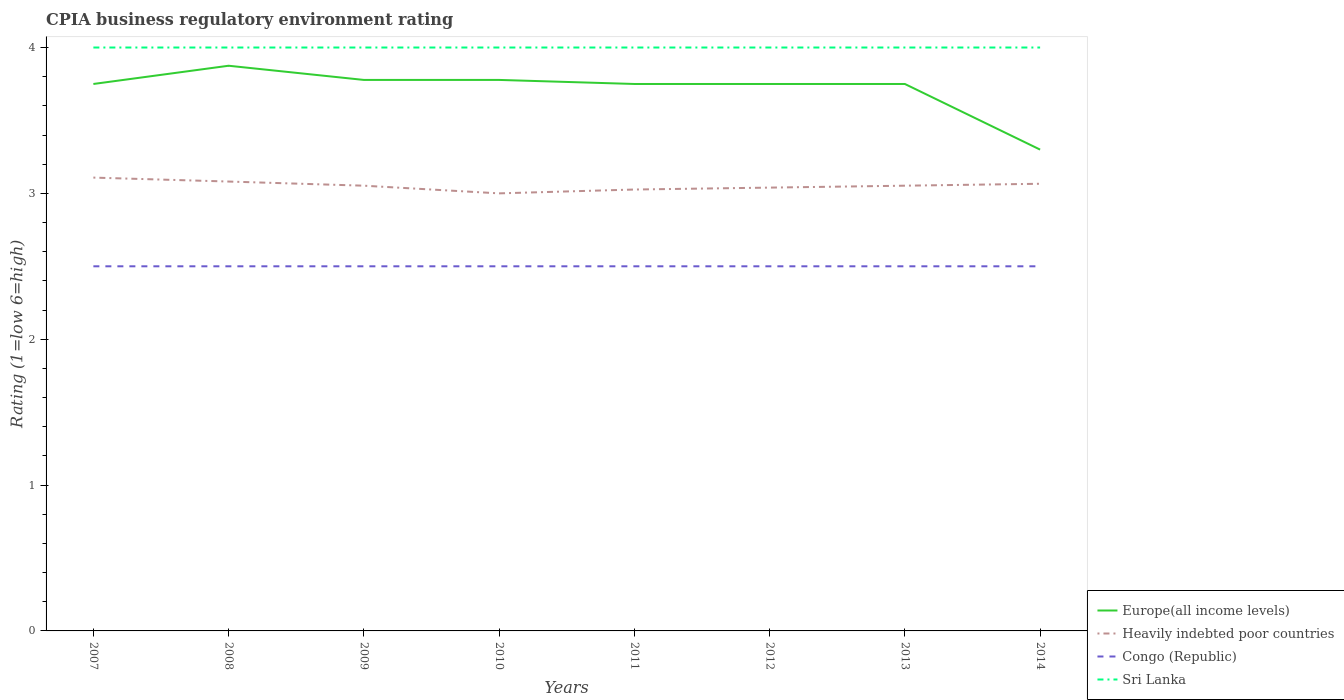Does the line corresponding to Heavily indebted poor countries intersect with the line corresponding to Congo (Republic)?
Make the answer very short. No. In which year was the CPIA rating in Heavily indebted poor countries maximum?
Offer a terse response. 2010. What is the total CPIA rating in Heavily indebted poor countries in the graph?
Keep it short and to the point. 0.03. What is the difference between the highest and the lowest CPIA rating in Sri Lanka?
Your response must be concise. 0. Is the CPIA rating in Congo (Republic) strictly greater than the CPIA rating in Heavily indebted poor countries over the years?
Provide a succinct answer. Yes. How many lines are there?
Keep it short and to the point. 4. How many years are there in the graph?
Offer a very short reply. 8. Are the values on the major ticks of Y-axis written in scientific E-notation?
Your answer should be very brief. No. Does the graph contain grids?
Your response must be concise. No. Where does the legend appear in the graph?
Your response must be concise. Bottom right. What is the title of the graph?
Offer a terse response. CPIA business regulatory environment rating. Does "Burkina Faso" appear as one of the legend labels in the graph?
Offer a very short reply. No. What is the label or title of the X-axis?
Ensure brevity in your answer.  Years. What is the Rating (1=low 6=high) in Europe(all income levels) in 2007?
Provide a succinct answer. 3.75. What is the Rating (1=low 6=high) of Heavily indebted poor countries in 2007?
Ensure brevity in your answer.  3.11. What is the Rating (1=low 6=high) of Sri Lanka in 2007?
Your response must be concise. 4. What is the Rating (1=low 6=high) of Europe(all income levels) in 2008?
Give a very brief answer. 3.88. What is the Rating (1=low 6=high) of Heavily indebted poor countries in 2008?
Make the answer very short. 3.08. What is the Rating (1=low 6=high) in Congo (Republic) in 2008?
Offer a terse response. 2.5. What is the Rating (1=low 6=high) in Europe(all income levels) in 2009?
Offer a terse response. 3.78. What is the Rating (1=low 6=high) of Heavily indebted poor countries in 2009?
Ensure brevity in your answer.  3.05. What is the Rating (1=low 6=high) in Congo (Republic) in 2009?
Provide a short and direct response. 2.5. What is the Rating (1=low 6=high) of Sri Lanka in 2009?
Offer a terse response. 4. What is the Rating (1=low 6=high) of Europe(all income levels) in 2010?
Your response must be concise. 3.78. What is the Rating (1=low 6=high) of Congo (Republic) in 2010?
Ensure brevity in your answer.  2.5. What is the Rating (1=low 6=high) in Europe(all income levels) in 2011?
Offer a terse response. 3.75. What is the Rating (1=low 6=high) of Heavily indebted poor countries in 2011?
Offer a very short reply. 3.03. What is the Rating (1=low 6=high) in Congo (Republic) in 2011?
Provide a succinct answer. 2.5. What is the Rating (1=low 6=high) in Europe(all income levels) in 2012?
Offer a very short reply. 3.75. What is the Rating (1=low 6=high) in Heavily indebted poor countries in 2012?
Your response must be concise. 3.04. What is the Rating (1=low 6=high) of Sri Lanka in 2012?
Ensure brevity in your answer.  4. What is the Rating (1=low 6=high) in Europe(all income levels) in 2013?
Ensure brevity in your answer.  3.75. What is the Rating (1=low 6=high) in Heavily indebted poor countries in 2013?
Your answer should be compact. 3.05. What is the Rating (1=low 6=high) of Heavily indebted poor countries in 2014?
Keep it short and to the point. 3.07. What is the Rating (1=low 6=high) of Congo (Republic) in 2014?
Give a very brief answer. 2.5. Across all years, what is the maximum Rating (1=low 6=high) of Europe(all income levels)?
Offer a very short reply. 3.88. Across all years, what is the maximum Rating (1=low 6=high) in Heavily indebted poor countries?
Keep it short and to the point. 3.11. Across all years, what is the maximum Rating (1=low 6=high) of Congo (Republic)?
Ensure brevity in your answer.  2.5. Across all years, what is the maximum Rating (1=low 6=high) in Sri Lanka?
Ensure brevity in your answer.  4. Across all years, what is the minimum Rating (1=low 6=high) of Congo (Republic)?
Offer a very short reply. 2.5. What is the total Rating (1=low 6=high) of Europe(all income levels) in the graph?
Make the answer very short. 29.73. What is the total Rating (1=low 6=high) of Heavily indebted poor countries in the graph?
Your answer should be compact. 24.43. What is the difference between the Rating (1=low 6=high) of Europe(all income levels) in 2007 and that in 2008?
Provide a succinct answer. -0.12. What is the difference between the Rating (1=low 6=high) in Heavily indebted poor countries in 2007 and that in 2008?
Provide a short and direct response. 0.03. What is the difference between the Rating (1=low 6=high) of Congo (Republic) in 2007 and that in 2008?
Make the answer very short. 0. What is the difference between the Rating (1=low 6=high) of Europe(all income levels) in 2007 and that in 2009?
Offer a very short reply. -0.03. What is the difference between the Rating (1=low 6=high) in Heavily indebted poor countries in 2007 and that in 2009?
Provide a succinct answer. 0.06. What is the difference between the Rating (1=low 6=high) of Europe(all income levels) in 2007 and that in 2010?
Your answer should be very brief. -0.03. What is the difference between the Rating (1=low 6=high) of Heavily indebted poor countries in 2007 and that in 2010?
Make the answer very short. 0.11. What is the difference between the Rating (1=low 6=high) of Congo (Republic) in 2007 and that in 2010?
Your response must be concise. 0. What is the difference between the Rating (1=low 6=high) of Heavily indebted poor countries in 2007 and that in 2011?
Your answer should be very brief. 0.08. What is the difference between the Rating (1=low 6=high) of Congo (Republic) in 2007 and that in 2011?
Make the answer very short. 0. What is the difference between the Rating (1=low 6=high) of Europe(all income levels) in 2007 and that in 2012?
Offer a terse response. 0. What is the difference between the Rating (1=low 6=high) in Heavily indebted poor countries in 2007 and that in 2012?
Your answer should be compact. 0.07. What is the difference between the Rating (1=low 6=high) in Europe(all income levels) in 2007 and that in 2013?
Your answer should be compact. 0. What is the difference between the Rating (1=low 6=high) in Heavily indebted poor countries in 2007 and that in 2013?
Make the answer very short. 0.06. What is the difference between the Rating (1=low 6=high) in Congo (Republic) in 2007 and that in 2013?
Make the answer very short. 0. What is the difference between the Rating (1=low 6=high) of Europe(all income levels) in 2007 and that in 2014?
Make the answer very short. 0.45. What is the difference between the Rating (1=low 6=high) of Heavily indebted poor countries in 2007 and that in 2014?
Make the answer very short. 0.04. What is the difference between the Rating (1=low 6=high) of Sri Lanka in 2007 and that in 2014?
Offer a very short reply. 0. What is the difference between the Rating (1=low 6=high) in Europe(all income levels) in 2008 and that in 2009?
Your answer should be compact. 0.1. What is the difference between the Rating (1=low 6=high) in Heavily indebted poor countries in 2008 and that in 2009?
Give a very brief answer. 0.03. What is the difference between the Rating (1=low 6=high) of Congo (Republic) in 2008 and that in 2009?
Provide a succinct answer. 0. What is the difference between the Rating (1=low 6=high) in Sri Lanka in 2008 and that in 2009?
Your response must be concise. 0. What is the difference between the Rating (1=low 6=high) in Europe(all income levels) in 2008 and that in 2010?
Provide a succinct answer. 0.1. What is the difference between the Rating (1=low 6=high) in Heavily indebted poor countries in 2008 and that in 2010?
Ensure brevity in your answer.  0.08. What is the difference between the Rating (1=low 6=high) of Congo (Republic) in 2008 and that in 2010?
Provide a succinct answer. 0. What is the difference between the Rating (1=low 6=high) of Europe(all income levels) in 2008 and that in 2011?
Offer a terse response. 0.12. What is the difference between the Rating (1=low 6=high) in Heavily indebted poor countries in 2008 and that in 2011?
Your answer should be very brief. 0.05. What is the difference between the Rating (1=low 6=high) in Congo (Republic) in 2008 and that in 2011?
Make the answer very short. 0. What is the difference between the Rating (1=low 6=high) in Sri Lanka in 2008 and that in 2011?
Offer a terse response. 0. What is the difference between the Rating (1=low 6=high) of Europe(all income levels) in 2008 and that in 2012?
Your response must be concise. 0.12. What is the difference between the Rating (1=low 6=high) in Heavily indebted poor countries in 2008 and that in 2012?
Make the answer very short. 0.04. What is the difference between the Rating (1=low 6=high) in Heavily indebted poor countries in 2008 and that in 2013?
Provide a succinct answer. 0.03. What is the difference between the Rating (1=low 6=high) in Congo (Republic) in 2008 and that in 2013?
Offer a very short reply. 0. What is the difference between the Rating (1=low 6=high) of Europe(all income levels) in 2008 and that in 2014?
Provide a succinct answer. 0.57. What is the difference between the Rating (1=low 6=high) in Heavily indebted poor countries in 2008 and that in 2014?
Keep it short and to the point. 0.02. What is the difference between the Rating (1=low 6=high) in Congo (Republic) in 2008 and that in 2014?
Offer a very short reply. 0. What is the difference between the Rating (1=low 6=high) in Europe(all income levels) in 2009 and that in 2010?
Make the answer very short. 0. What is the difference between the Rating (1=low 6=high) in Heavily indebted poor countries in 2009 and that in 2010?
Your response must be concise. 0.05. What is the difference between the Rating (1=low 6=high) in Congo (Republic) in 2009 and that in 2010?
Your response must be concise. 0. What is the difference between the Rating (1=low 6=high) of Sri Lanka in 2009 and that in 2010?
Offer a very short reply. 0. What is the difference between the Rating (1=low 6=high) of Europe(all income levels) in 2009 and that in 2011?
Provide a short and direct response. 0.03. What is the difference between the Rating (1=low 6=high) in Heavily indebted poor countries in 2009 and that in 2011?
Give a very brief answer. 0.03. What is the difference between the Rating (1=low 6=high) in Sri Lanka in 2009 and that in 2011?
Make the answer very short. 0. What is the difference between the Rating (1=low 6=high) in Europe(all income levels) in 2009 and that in 2012?
Your answer should be compact. 0.03. What is the difference between the Rating (1=low 6=high) of Heavily indebted poor countries in 2009 and that in 2012?
Offer a terse response. 0.01. What is the difference between the Rating (1=low 6=high) of Sri Lanka in 2009 and that in 2012?
Provide a short and direct response. 0. What is the difference between the Rating (1=low 6=high) of Europe(all income levels) in 2009 and that in 2013?
Provide a succinct answer. 0.03. What is the difference between the Rating (1=low 6=high) of Heavily indebted poor countries in 2009 and that in 2013?
Offer a very short reply. 0. What is the difference between the Rating (1=low 6=high) in Sri Lanka in 2009 and that in 2013?
Keep it short and to the point. 0. What is the difference between the Rating (1=low 6=high) in Europe(all income levels) in 2009 and that in 2014?
Your answer should be very brief. 0.48. What is the difference between the Rating (1=low 6=high) in Heavily indebted poor countries in 2009 and that in 2014?
Offer a very short reply. -0.01. What is the difference between the Rating (1=low 6=high) of Europe(all income levels) in 2010 and that in 2011?
Your answer should be very brief. 0.03. What is the difference between the Rating (1=low 6=high) in Heavily indebted poor countries in 2010 and that in 2011?
Make the answer very short. -0.03. What is the difference between the Rating (1=low 6=high) of Europe(all income levels) in 2010 and that in 2012?
Offer a very short reply. 0.03. What is the difference between the Rating (1=low 6=high) in Heavily indebted poor countries in 2010 and that in 2012?
Make the answer very short. -0.04. What is the difference between the Rating (1=low 6=high) of Congo (Republic) in 2010 and that in 2012?
Make the answer very short. 0. What is the difference between the Rating (1=low 6=high) of Europe(all income levels) in 2010 and that in 2013?
Make the answer very short. 0.03. What is the difference between the Rating (1=low 6=high) in Heavily indebted poor countries in 2010 and that in 2013?
Provide a succinct answer. -0.05. What is the difference between the Rating (1=low 6=high) in Congo (Republic) in 2010 and that in 2013?
Provide a short and direct response. 0. What is the difference between the Rating (1=low 6=high) of Sri Lanka in 2010 and that in 2013?
Keep it short and to the point. 0. What is the difference between the Rating (1=low 6=high) in Europe(all income levels) in 2010 and that in 2014?
Offer a very short reply. 0.48. What is the difference between the Rating (1=low 6=high) in Heavily indebted poor countries in 2010 and that in 2014?
Your response must be concise. -0.07. What is the difference between the Rating (1=low 6=high) of Sri Lanka in 2010 and that in 2014?
Keep it short and to the point. 0. What is the difference between the Rating (1=low 6=high) of Europe(all income levels) in 2011 and that in 2012?
Keep it short and to the point. 0. What is the difference between the Rating (1=low 6=high) of Heavily indebted poor countries in 2011 and that in 2012?
Offer a very short reply. -0.01. What is the difference between the Rating (1=low 6=high) in Heavily indebted poor countries in 2011 and that in 2013?
Make the answer very short. -0.03. What is the difference between the Rating (1=low 6=high) of Sri Lanka in 2011 and that in 2013?
Your response must be concise. 0. What is the difference between the Rating (1=low 6=high) of Europe(all income levels) in 2011 and that in 2014?
Your response must be concise. 0.45. What is the difference between the Rating (1=low 6=high) in Heavily indebted poor countries in 2011 and that in 2014?
Your response must be concise. -0.04. What is the difference between the Rating (1=low 6=high) in Congo (Republic) in 2011 and that in 2014?
Provide a succinct answer. 0. What is the difference between the Rating (1=low 6=high) of Sri Lanka in 2011 and that in 2014?
Offer a terse response. 0. What is the difference between the Rating (1=low 6=high) of Heavily indebted poor countries in 2012 and that in 2013?
Offer a terse response. -0.01. What is the difference between the Rating (1=low 6=high) of Europe(all income levels) in 2012 and that in 2014?
Provide a short and direct response. 0.45. What is the difference between the Rating (1=low 6=high) of Heavily indebted poor countries in 2012 and that in 2014?
Keep it short and to the point. -0.03. What is the difference between the Rating (1=low 6=high) of Sri Lanka in 2012 and that in 2014?
Provide a short and direct response. 0. What is the difference between the Rating (1=low 6=high) of Europe(all income levels) in 2013 and that in 2014?
Make the answer very short. 0.45. What is the difference between the Rating (1=low 6=high) in Heavily indebted poor countries in 2013 and that in 2014?
Make the answer very short. -0.01. What is the difference between the Rating (1=low 6=high) of Congo (Republic) in 2013 and that in 2014?
Your answer should be compact. 0. What is the difference between the Rating (1=low 6=high) in Europe(all income levels) in 2007 and the Rating (1=low 6=high) in Heavily indebted poor countries in 2008?
Ensure brevity in your answer.  0.67. What is the difference between the Rating (1=low 6=high) in Europe(all income levels) in 2007 and the Rating (1=low 6=high) in Congo (Republic) in 2008?
Your answer should be compact. 1.25. What is the difference between the Rating (1=low 6=high) of Heavily indebted poor countries in 2007 and the Rating (1=low 6=high) of Congo (Republic) in 2008?
Ensure brevity in your answer.  0.61. What is the difference between the Rating (1=low 6=high) in Heavily indebted poor countries in 2007 and the Rating (1=low 6=high) in Sri Lanka in 2008?
Make the answer very short. -0.89. What is the difference between the Rating (1=low 6=high) of Congo (Republic) in 2007 and the Rating (1=low 6=high) of Sri Lanka in 2008?
Ensure brevity in your answer.  -1.5. What is the difference between the Rating (1=low 6=high) of Europe(all income levels) in 2007 and the Rating (1=low 6=high) of Heavily indebted poor countries in 2009?
Offer a very short reply. 0.7. What is the difference between the Rating (1=low 6=high) of Europe(all income levels) in 2007 and the Rating (1=low 6=high) of Congo (Republic) in 2009?
Keep it short and to the point. 1.25. What is the difference between the Rating (1=low 6=high) of Heavily indebted poor countries in 2007 and the Rating (1=low 6=high) of Congo (Republic) in 2009?
Ensure brevity in your answer.  0.61. What is the difference between the Rating (1=low 6=high) in Heavily indebted poor countries in 2007 and the Rating (1=low 6=high) in Sri Lanka in 2009?
Make the answer very short. -0.89. What is the difference between the Rating (1=low 6=high) of Congo (Republic) in 2007 and the Rating (1=low 6=high) of Sri Lanka in 2009?
Keep it short and to the point. -1.5. What is the difference between the Rating (1=low 6=high) of Heavily indebted poor countries in 2007 and the Rating (1=low 6=high) of Congo (Republic) in 2010?
Provide a succinct answer. 0.61. What is the difference between the Rating (1=low 6=high) of Heavily indebted poor countries in 2007 and the Rating (1=low 6=high) of Sri Lanka in 2010?
Provide a short and direct response. -0.89. What is the difference between the Rating (1=low 6=high) of Congo (Republic) in 2007 and the Rating (1=low 6=high) of Sri Lanka in 2010?
Your answer should be very brief. -1.5. What is the difference between the Rating (1=low 6=high) of Europe(all income levels) in 2007 and the Rating (1=low 6=high) of Heavily indebted poor countries in 2011?
Keep it short and to the point. 0.72. What is the difference between the Rating (1=low 6=high) in Heavily indebted poor countries in 2007 and the Rating (1=low 6=high) in Congo (Republic) in 2011?
Make the answer very short. 0.61. What is the difference between the Rating (1=low 6=high) in Heavily indebted poor countries in 2007 and the Rating (1=low 6=high) in Sri Lanka in 2011?
Offer a very short reply. -0.89. What is the difference between the Rating (1=low 6=high) in Congo (Republic) in 2007 and the Rating (1=low 6=high) in Sri Lanka in 2011?
Make the answer very short. -1.5. What is the difference between the Rating (1=low 6=high) of Europe(all income levels) in 2007 and the Rating (1=low 6=high) of Heavily indebted poor countries in 2012?
Make the answer very short. 0.71. What is the difference between the Rating (1=low 6=high) in Europe(all income levels) in 2007 and the Rating (1=low 6=high) in Congo (Republic) in 2012?
Your response must be concise. 1.25. What is the difference between the Rating (1=low 6=high) of Europe(all income levels) in 2007 and the Rating (1=low 6=high) of Sri Lanka in 2012?
Offer a terse response. -0.25. What is the difference between the Rating (1=low 6=high) in Heavily indebted poor countries in 2007 and the Rating (1=low 6=high) in Congo (Republic) in 2012?
Keep it short and to the point. 0.61. What is the difference between the Rating (1=low 6=high) of Heavily indebted poor countries in 2007 and the Rating (1=low 6=high) of Sri Lanka in 2012?
Your answer should be very brief. -0.89. What is the difference between the Rating (1=low 6=high) in Congo (Republic) in 2007 and the Rating (1=low 6=high) in Sri Lanka in 2012?
Offer a terse response. -1.5. What is the difference between the Rating (1=low 6=high) of Europe(all income levels) in 2007 and the Rating (1=low 6=high) of Heavily indebted poor countries in 2013?
Give a very brief answer. 0.7. What is the difference between the Rating (1=low 6=high) in Europe(all income levels) in 2007 and the Rating (1=low 6=high) in Congo (Republic) in 2013?
Offer a terse response. 1.25. What is the difference between the Rating (1=low 6=high) of Heavily indebted poor countries in 2007 and the Rating (1=low 6=high) of Congo (Republic) in 2013?
Ensure brevity in your answer.  0.61. What is the difference between the Rating (1=low 6=high) of Heavily indebted poor countries in 2007 and the Rating (1=low 6=high) of Sri Lanka in 2013?
Offer a very short reply. -0.89. What is the difference between the Rating (1=low 6=high) of Europe(all income levels) in 2007 and the Rating (1=low 6=high) of Heavily indebted poor countries in 2014?
Your answer should be very brief. 0.68. What is the difference between the Rating (1=low 6=high) in Heavily indebted poor countries in 2007 and the Rating (1=low 6=high) in Congo (Republic) in 2014?
Provide a short and direct response. 0.61. What is the difference between the Rating (1=low 6=high) of Heavily indebted poor countries in 2007 and the Rating (1=low 6=high) of Sri Lanka in 2014?
Your answer should be compact. -0.89. What is the difference between the Rating (1=low 6=high) of Europe(all income levels) in 2008 and the Rating (1=low 6=high) of Heavily indebted poor countries in 2009?
Make the answer very short. 0.82. What is the difference between the Rating (1=low 6=high) of Europe(all income levels) in 2008 and the Rating (1=low 6=high) of Congo (Republic) in 2009?
Keep it short and to the point. 1.38. What is the difference between the Rating (1=low 6=high) in Europe(all income levels) in 2008 and the Rating (1=low 6=high) in Sri Lanka in 2009?
Offer a terse response. -0.12. What is the difference between the Rating (1=low 6=high) of Heavily indebted poor countries in 2008 and the Rating (1=low 6=high) of Congo (Republic) in 2009?
Give a very brief answer. 0.58. What is the difference between the Rating (1=low 6=high) in Heavily indebted poor countries in 2008 and the Rating (1=low 6=high) in Sri Lanka in 2009?
Your response must be concise. -0.92. What is the difference between the Rating (1=low 6=high) in Congo (Republic) in 2008 and the Rating (1=low 6=high) in Sri Lanka in 2009?
Your answer should be very brief. -1.5. What is the difference between the Rating (1=low 6=high) of Europe(all income levels) in 2008 and the Rating (1=low 6=high) of Heavily indebted poor countries in 2010?
Ensure brevity in your answer.  0.88. What is the difference between the Rating (1=low 6=high) in Europe(all income levels) in 2008 and the Rating (1=low 6=high) in Congo (Republic) in 2010?
Offer a terse response. 1.38. What is the difference between the Rating (1=low 6=high) in Europe(all income levels) in 2008 and the Rating (1=low 6=high) in Sri Lanka in 2010?
Your answer should be compact. -0.12. What is the difference between the Rating (1=low 6=high) of Heavily indebted poor countries in 2008 and the Rating (1=low 6=high) of Congo (Republic) in 2010?
Offer a very short reply. 0.58. What is the difference between the Rating (1=low 6=high) in Heavily indebted poor countries in 2008 and the Rating (1=low 6=high) in Sri Lanka in 2010?
Make the answer very short. -0.92. What is the difference between the Rating (1=low 6=high) in Europe(all income levels) in 2008 and the Rating (1=low 6=high) in Heavily indebted poor countries in 2011?
Make the answer very short. 0.85. What is the difference between the Rating (1=low 6=high) of Europe(all income levels) in 2008 and the Rating (1=low 6=high) of Congo (Republic) in 2011?
Keep it short and to the point. 1.38. What is the difference between the Rating (1=low 6=high) in Europe(all income levels) in 2008 and the Rating (1=low 6=high) in Sri Lanka in 2011?
Ensure brevity in your answer.  -0.12. What is the difference between the Rating (1=low 6=high) in Heavily indebted poor countries in 2008 and the Rating (1=low 6=high) in Congo (Republic) in 2011?
Provide a succinct answer. 0.58. What is the difference between the Rating (1=low 6=high) of Heavily indebted poor countries in 2008 and the Rating (1=low 6=high) of Sri Lanka in 2011?
Offer a terse response. -0.92. What is the difference between the Rating (1=low 6=high) of Congo (Republic) in 2008 and the Rating (1=low 6=high) of Sri Lanka in 2011?
Give a very brief answer. -1.5. What is the difference between the Rating (1=low 6=high) of Europe(all income levels) in 2008 and the Rating (1=low 6=high) of Heavily indebted poor countries in 2012?
Give a very brief answer. 0.84. What is the difference between the Rating (1=low 6=high) in Europe(all income levels) in 2008 and the Rating (1=low 6=high) in Congo (Republic) in 2012?
Your answer should be very brief. 1.38. What is the difference between the Rating (1=low 6=high) of Europe(all income levels) in 2008 and the Rating (1=low 6=high) of Sri Lanka in 2012?
Ensure brevity in your answer.  -0.12. What is the difference between the Rating (1=low 6=high) of Heavily indebted poor countries in 2008 and the Rating (1=low 6=high) of Congo (Republic) in 2012?
Keep it short and to the point. 0.58. What is the difference between the Rating (1=low 6=high) in Heavily indebted poor countries in 2008 and the Rating (1=low 6=high) in Sri Lanka in 2012?
Your answer should be very brief. -0.92. What is the difference between the Rating (1=low 6=high) of Congo (Republic) in 2008 and the Rating (1=low 6=high) of Sri Lanka in 2012?
Give a very brief answer. -1.5. What is the difference between the Rating (1=low 6=high) in Europe(all income levels) in 2008 and the Rating (1=low 6=high) in Heavily indebted poor countries in 2013?
Your answer should be very brief. 0.82. What is the difference between the Rating (1=low 6=high) in Europe(all income levels) in 2008 and the Rating (1=low 6=high) in Congo (Republic) in 2013?
Keep it short and to the point. 1.38. What is the difference between the Rating (1=low 6=high) of Europe(all income levels) in 2008 and the Rating (1=low 6=high) of Sri Lanka in 2013?
Make the answer very short. -0.12. What is the difference between the Rating (1=low 6=high) in Heavily indebted poor countries in 2008 and the Rating (1=low 6=high) in Congo (Republic) in 2013?
Keep it short and to the point. 0.58. What is the difference between the Rating (1=low 6=high) in Heavily indebted poor countries in 2008 and the Rating (1=low 6=high) in Sri Lanka in 2013?
Offer a very short reply. -0.92. What is the difference between the Rating (1=low 6=high) in Congo (Republic) in 2008 and the Rating (1=low 6=high) in Sri Lanka in 2013?
Your answer should be compact. -1.5. What is the difference between the Rating (1=low 6=high) in Europe(all income levels) in 2008 and the Rating (1=low 6=high) in Heavily indebted poor countries in 2014?
Ensure brevity in your answer.  0.81. What is the difference between the Rating (1=low 6=high) in Europe(all income levels) in 2008 and the Rating (1=low 6=high) in Congo (Republic) in 2014?
Keep it short and to the point. 1.38. What is the difference between the Rating (1=low 6=high) of Europe(all income levels) in 2008 and the Rating (1=low 6=high) of Sri Lanka in 2014?
Ensure brevity in your answer.  -0.12. What is the difference between the Rating (1=low 6=high) in Heavily indebted poor countries in 2008 and the Rating (1=low 6=high) in Congo (Republic) in 2014?
Provide a short and direct response. 0.58. What is the difference between the Rating (1=low 6=high) of Heavily indebted poor countries in 2008 and the Rating (1=low 6=high) of Sri Lanka in 2014?
Ensure brevity in your answer.  -0.92. What is the difference between the Rating (1=low 6=high) in Congo (Republic) in 2008 and the Rating (1=low 6=high) in Sri Lanka in 2014?
Your response must be concise. -1.5. What is the difference between the Rating (1=low 6=high) in Europe(all income levels) in 2009 and the Rating (1=low 6=high) in Heavily indebted poor countries in 2010?
Your answer should be compact. 0.78. What is the difference between the Rating (1=low 6=high) in Europe(all income levels) in 2009 and the Rating (1=low 6=high) in Congo (Republic) in 2010?
Your answer should be very brief. 1.28. What is the difference between the Rating (1=low 6=high) in Europe(all income levels) in 2009 and the Rating (1=low 6=high) in Sri Lanka in 2010?
Offer a terse response. -0.22. What is the difference between the Rating (1=low 6=high) of Heavily indebted poor countries in 2009 and the Rating (1=low 6=high) of Congo (Republic) in 2010?
Give a very brief answer. 0.55. What is the difference between the Rating (1=low 6=high) of Heavily indebted poor countries in 2009 and the Rating (1=low 6=high) of Sri Lanka in 2010?
Your response must be concise. -0.95. What is the difference between the Rating (1=low 6=high) of Europe(all income levels) in 2009 and the Rating (1=low 6=high) of Heavily indebted poor countries in 2011?
Your answer should be compact. 0.75. What is the difference between the Rating (1=low 6=high) of Europe(all income levels) in 2009 and the Rating (1=low 6=high) of Congo (Republic) in 2011?
Ensure brevity in your answer.  1.28. What is the difference between the Rating (1=low 6=high) of Europe(all income levels) in 2009 and the Rating (1=low 6=high) of Sri Lanka in 2011?
Keep it short and to the point. -0.22. What is the difference between the Rating (1=low 6=high) in Heavily indebted poor countries in 2009 and the Rating (1=low 6=high) in Congo (Republic) in 2011?
Offer a terse response. 0.55. What is the difference between the Rating (1=low 6=high) of Heavily indebted poor countries in 2009 and the Rating (1=low 6=high) of Sri Lanka in 2011?
Your answer should be compact. -0.95. What is the difference between the Rating (1=low 6=high) in Congo (Republic) in 2009 and the Rating (1=low 6=high) in Sri Lanka in 2011?
Provide a succinct answer. -1.5. What is the difference between the Rating (1=low 6=high) in Europe(all income levels) in 2009 and the Rating (1=low 6=high) in Heavily indebted poor countries in 2012?
Keep it short and to the point. 0.74. What is the difference between the Rating (1=low 6=high) in Europe(all income levels) in 2009 and the Rating (1=low 6=high) in Congo (Republic) in 2012?
Offer a terse response. 1.28. What is the difference between the Rating (1=low 6=high) of Europe(all income levels) in 2009 and the Rating (1=low 6=high) of Sri Lanka in 2012?
Your answer should be very brief. -0.22. What is the difference between the Rating (1=low 6=high) in Heavily indebted poor countries in 2009 and the Rating (1=low 6=high) in Congo (Republic) in 2012?
Your answer should be very brief. 0.55. What is the difference between the Rating (1=low 6=high) of Heavily indebted poor countries in 2009 and the Rating (1=low 6=high) of Sri Lanka in 2012?
Offer a very short reply. -0.95. What is the difference between the Rating (1=low 6=high) in Europe(all income levels) in 2009 and the Rating (1=low 6=high) in Heavily indebted poor countries in 2013?
Your response must be concise. 0.73. What is the difference between the Rating (1=low 6=high) in Europe(all income levels) in 2009 and the Rating (1=low 6=high) in Congo (Republic) in 2013?
Keep it short and to the point. 1.28. What is the difference between the Rating (1=low 6=high) of Europe(all income levels) in 2009 and the Rating (1=low 6=high) of Sri Lanka in 2013?
Offer a very short reply. -0.22. What is the difference between the Rating (1=low 6=high) in Heavily indebted poor countries in 2009 and the Rating (1=low 6=high) in Congo (Republic) in 2013?
Provide a short and direct response. 0.55. What is the difference between the Rating (1=low 6=high) in Heavily indebted poor countries in 2009 and the Rating (1=low 6=high) in Sri Lanka in 2013?
Your response must be concise. -0.95. What is the difference between the Rating (1=low 6=high) of Congo (Republic) in 2009 and the Rating (1=low 6=high) of Sri Lanka in 2013?
Keep it short and to the point. -1.5. What is the difference between the Rating (1=low 6=high) in Europe(all income levels) in 2009 and the Rating (1=low 6=high) in Heavily indebted poor countries in 2014?
Keep it short and to the point. 0.71. What is the difference between the Rating (1=low 6=high) in Europe(all income levels) in 2009 and the Rating (1=low 6=high) in Congo (Republic) in 2014?
Keep it short and to the point. 1.28. What is the difference between the Rating (1=low 6=high) in Europe(all income levels) in 2009 and the Rating (1=low 6=high) in Sri Lanka in 2014?
Provide a succinct answer. -0.22. What is the difference between the Rating (1=low 6=high) of Heavily indebted poor countries in 2009 and the Rating (1=low 6=high) of Congo (Republic) in 2014?
Offer a very short reply. 0.55. What is the difference between the Rating (1=low 6=high) in Heavily indebted poor countries in 2009 and the Rating (1=low 6=high) in Sri Lanka in 2014?
Your answer should be compact. -0.95. What is the difference between the Rating (1=low 6=high) in Congo (Republic) in 2009 and the Rating (1=low 6=high) in Sri Lanka in 2014?
Your response must be concise. -1.5. What is the difference between the Rating (1=low 6=high) of Europe(all income levels) in 2010 and the Rating (1=low 6=high) of Heavily indebted poor countries in 2011?
Provide a succinct answer. 0.75. What is the difference between the Rating (1=low 6=high) of Europe(all income levels) in 2010 and the Rating (1=low 6=high) of Congo (Republic) in 2011?
Keep it short and to the point. 1.28. What is the difference between the Rating (1=low 6=high) in Europe(all income levels) in 2010 and the Rating (1=low 6=high) in Sri Lanka in 2011?
Keep it short and to the point. -0.22. What is the difference between the Rating (1=low 6=high) of Heavily indebted poor countries in 2010 and the Rating (1=low 6=high) of Sri Lanka in 2011?
Give a very brief answer. -1. What is the difference between the Rating (1=low 6=high) of Europe(all income levels) in 2010 and the Rating (1=low 6=high) of Heavily indebted poor countries in 2012?
Your response must be concise. 0.74. What is the difference between the Rating (1=low 6=high) in Europe(all income levels) in 2010 and the Rating (1=low 6=high) in Congo (Republic) in 2012?
Your answer should be compact. 1.28. What is the difference between the Rating (1=low 6=high) in Europe(all income levels) in 2010 and the Rating (1=low 6=high) in Sri Lanka in 2012?
Your response must be concise. -0.22. What is the difference between the Rating (1=low 6=high) in Europe(all income levels) in 2010 and the Rating (1=low 6=high) in Heavily indebted poor countries in 2013?
Your answer should be compact. 0.73. What is the difference between the Rating (1=low 6=high) in Europe(all income levels) in 2010 and the Rating (1=low 6=high) in Congo (Republic) in 2013?
Keep it short and to the point. 1.28. What is the difference between the Rating (1=low 6=high) of Europe(all income levels) in 2010 and the Rating (1=low 6=high) of Sri Lanka in 2013?
Make the answer very short. -0.22. What is the difference between the Rating (1=low 6=high) of Heavily indebted poor countries in 2010 and the Rating (1=low 6=high) of Congo (Republic) in 2013?
Provide a succinct answer. 0.5. What is the difference between the Rating (1=low 6=high) of Heavily indebted poor countries in 2010 and the Rating (1=low 6=high) of Sri Lanka in 2013?
Keep it short and to the point. -1. What is the difference between the Rating (1=low 6=high) in Congo (Republic) in 2010 and the Rating (1=low 6=high) in Sri Lanka in 2013?
Your response must be concise. -1.5. What is the difference between the Rating (1=low 6=high) in Europe(all income levels) in 2010 and the Rating (1=low 6=high) in Heavily indebted poor countries in 2014?
Keep it short and to the point. 0.71. What is the difference between the Rating (1=low 6=high) of Europe(all income levels) in 2010 and the Rating (1=low 6=high) of Congo (Republic) in 2014?
Ensure brevity in your answer.  1.28. What is the difference between the Rating (1=low 6=high) of Europe(all income levels) in 2010 and the Rating (1=low 6=high) of Sri Lanka in 2014?
Offer a very short reply. -0.22. What is the difference between the Rating (1=low 6=high) in Congo (Republic) in 2010 and the Rating (1=low 6=high) in Sri Lanka in 2014?
Keep it short and to the point. -1.5. What is the difference between the Rating (1=low 6=high) in Europe(all income levels) in 2011 and the Rating (1=low 6=high) in Heavily indebted poor countries in 2012?
Your answer should be compact. 0.71. What is the difference between the Rating (1=low 6=high) of Europe(all income levels) in 2011 and the Rating (1=low 6=high) of Sri Lanka in 2012?
Your answer should be compact. -0.25. What is the difference between the Rating (1=low 6=high) of Heavily indebted poor countries in 2011 and the Rating (1=low 6=high) of Congo (Republic) in 2012?
Your answer should be very brief. 0.53. What is the difference between the Rating (1=low 6=high) in Heavily indebted poor countries in 2011 and the Rating (1=low 6=high) in Sri Lanka in 2012?
Keep it short and to the point. -0.97. What is the difference between the Rating (1=low 6=high) in Congo (Republic) in 2011 and the Rating (1=low 6=high) in Sri Lanka in 2012?
Provide a succinct answer. -1.5. What is the difference between the Rating (1=low 6=high) in Europe(all income levels) in 2011 and the Rating (1=low 6=high) in Heavily indebted poor countries in 2013?
Your answer should be very brief. 0.7. What is the difference between the Rating (1=low 6=high) of Europe(all income levels) in 2011 and the Rating (1=low 6=high) of Congo (Republic) in 2013?
Offer a very short reply. 1.25. What is the difference between the Rating (1=low 6=high) of Heavily indebted poor countries in 2011 and the Rating (1=low 6=high) of Congo (Republic) in 2013?
Offer a very short reply. 0.53. What is the difference between the Rating (1=low 6=high) in Heavily indebted poor countries in 2011 and the Rating (1=low 6=high) in Sri Lanka in 2013?
Offer a terse response. -0.97. What is the difference between the Rating (1=low 6=high) of Europe(all income levels) in 2011 and the Rating (1=low 6=high) of Heavily indebted poor countries in 2014?
Keep it short and to the point. 0.68. What is the difference between the Rating (1=low 6=high) of Heavily indebted poor countries in 2011 and the Rating (1=low 6=high) of Congo (Republic) in 2014?
Offer a terse response. 0.53. What is the difference between the Rating (1=low 6=high) in Heavily indebted poor countries in 2011 and the Rating (1=low 6=high) in Sri Lanka in 2014?
Give a very brief answer. -0.97. What is the difference between the Rating (1=low 6=high) of Europe(all income levels) in 2012 and the Rating (1=low 6=high) of Heavily indebted poor countries in 2013?
Keep it short and to the point. 0.7. What is the difference between the Rating (1=low 6=high) of Europe(all income levels) in 2012 and the Rating (1=low 6=high) of Sri Lanka in 2013?
Give a very brief answer. -0.25. What is the difference between the Rating (1=low 6=high) in Heavily indebted poor countries in 2012 and the Rating (1=low 6=high) in Congo (Republic) in 2013?
Provide a succinct answer. 0.54. What is the difference between the Rating (1=low 6=high) of Heavily indebted poor countries in 2012 and the Rating (1=low 6=high) of Sri Lanka in 2013?
Provide a succinct answer. -0.96. What is the difference between the Rating (1=low 6=high) in Congo (Republic) in 2012 and the Rating (1=low 6=high) in Sri Lanka in 2013?
Ensure brevity in your answer.  -1.5. What is the difference between the Rating (1=low 6=high) of Europe(all income levels) in 2012 and the Rating (1=low 6=high) of Heavily indebted poor countries in 2014?
Provide a short and direct response. 0.68. What is the difference between the Rating (1=low 6=high) of Heavily indebted poor countries in 2012 and the Rating (1=low 6=high) of Congo (Republic) in 2014?
Offer a terse response. 0.54. What is the difference between the Rating (1=low 6=high) in Heavily indebted poor countries in 2012 and the Rating (1=low 6=high) in Sri Lanka in 2014?
Ensure brevity in your answer.  -0.96. What is the difference between the Rating (1=low 6=high) in Europe(all income levels) in 2013 and the Rating (1=low 6=high) in Heavily indebted poor countries in 2014?
Make the answer very short. 0.68. What is the difference between the Rating (1=low 6=high) in Europe(all income levels) in 2013 and the Rating (1=low 6=high) in Congo (Republic) in 2014?
Ensure brevity in your answer.  1.25. What is the difference between the Rating (1=low 6=high) in Europe(all income levels) in 2013 and the Rating (1=low 6=high) in Sri Lanka in 2014?
Ensure brevity in your answer.  -0.25. What is the difference between the Rating (1=low 6=high) in Heavily indebted poor countries in 2013 and the Rating (1=low 6=high) in Congo (Republic) in 2014?
Offer a terse response. 0.55. What is the difference between the Rating (1=low 6=high) in Heavily indebted poor countries in 2013 and the Rating (1=low 6=high) in Sri Lanka in 2014?
Offer a very short reply. -0.95. What is the average Rating (1=low 6=high) of Europe(all income levels) per year?
Give a very brief answer. 3.72. What is the average Rating (1=low 6=high) of Heavily indebted poor countries per year?
Your response must be concise. 3.05. In the year 2007, what is the difference between the Rating (1=low 6=high) of Europe(all income levels) and Rating (1=low 6=high) of Heavily indebted poor countries?
Ensure brevity in your answer.  0.64. In the year 2007, what is the difference between the Rating (1=low 6=high) in Europe(all income levels) and Rating (1=low 6=high) in Sri Lanka?
Give a very brief answer. -0.25. In the year 2007, what is the difference between the Rating (1=low 6=high) of Heavily indebted poor countries and Rating (1=low 6=high) of Congo (Republic)?
Give a very brief answer. 0.61. In the year 2007, what is the difference between the Rating (1=low 6=high) of Heavily indebted poor countries and Rating (1=low 6=high) of Sri Lanka?
Give a very brief answer. -0.89. In the year 2007, what is the difference between the Rating (1=low 6=high) in Congo (Republic) and Rating (1=low 6=high) in Sri Lanka?
Offer a very short reply. -1.5. In the year 2008, what is the difference between the Rating (1=low 6=high) of Europe(all income levels) and Rating (1=low 6=high) of Heavily indebted poor countries?
Offer a very short reply. 0.79. In the year 2008, what is the difference between the Rating (1=low 6=high) in Europe(all income levels) and Rating (1=low 6=high) in Congo (Republic)?
Offer a terse response. 1.38. In the year 2008, what is the difference between the Rating (1=low 6=high) in Europe(all income levels) and Rating (1=low 6=high) in Sri Lanka?
Keep it short and to the point. -0.12. In the year 2008, what is the difference between the Rating (1=low 6=high) of Heavily indebted poor countries and Rating (1=low 6=high) of Congo (Republic)?
Offer a very short reply. 0.58. In the year 2008, what is the difference between the Rating (1=low 6=high) in Heavily indebted poor countries and Rating (1=low 6=high) in Sri Lanka?
Ensure brevity in your answer.  -0.92. In the year 2009, what is the difference between the Rating (1=low 6=high) in Europe(all income levels) and Rating (1=low 6=high) in Heavily indebted poor countries?
Give a very brief answer. 0.73. In the year 2009, what is the difference between the Rating (1=low 6=high) in Europe(all income levels) and Rating (1=low 6=high) in Congo (Republic)?
Keep it short and to the point. 1.28. In the year 2009, what is the difference between the Rating (1=low 6=high) of Europe(all income levels) and Rating (1=low 6=high) of Sri Lanka?
Make the answer very short. -0.22. In the year 2009, what is the difference between the Rating (1=low 6=high) in Heavily indebted poor countries and Rating (1=low 6=high) in Congo (Republic)?
Make the answer very short. 0.55. In the year 2009, what is the difference between the Rating (1=low 6=high) in Heavily indebted poor countries and Rating (1=low 6=high) in Sri Lanka?
Your answer should be very brief. -0.95. In the year 2010, what is the difference between the Rating (1=low 6=high) of Europe(all income levels) and Rating (1=low 6=high) of Heavily indebted poor countries?
Ensure brevity in your answer.  0.78. In the year 2010, what is the difference between the Rating (1=low 6=high) of Europe(all income levels) and Rating (1=low 6=high) of Congo (Republic)?
Keep it short and to the point. 1.28. In the year 2010, what is the difference between the Rating (1=low 6=high) in Europe(all income levels) and Rating (1=low 6=high) in Sri Lanka?
Provide a succinct answer. -0.22. In the year 2010, what is the difference between the Rating (1=low 6=high) in Congo (Republic) and Rating (1=low 6=high) in Sri Lanka?
Your answer should be very brief. -1.5. In the year 2011, what is the difference between the Rating (1=low 6=high) of Europe(all income levels) and Rating (1=low 6=high) of Heavily indebted poor countries?
Offer a terse response. 0.72. In the year 2011, what is the difference between the Rating (1=low 6=high) of Europe(all income levels) and Rating (1=low 6=high) of Congo (Republic)?
Keep it short and to the point. 1.25. In the year 2011, what is the difference between the Rating (1=low 6=high) in Heavily indebted poor countries and Rating (1=low 6=high) in Congo (Republic)?
Provide a succinct answer. 0.53. In the year 2011, what is the difference between the Rating (1=low 6=high) in Heavily indebted poor countries and Rating (1=low 6=high) in Sri Lanka?
Your response must be concise. -0.97. In the year 2011, what is the difference between the Rating (1=low 6=high) in Congo (Republic) and Rating (1=low 6=high) in Sri Lanka?
Offer a terse response. -1.5. In the year 2012, what is the difference between the Rating (1=low 6=high) in Europe(all income levels) and Rating (1=low 6=high) in Heavily indebted poor countries?
Make the answer very short. 0.71. In the year 2012, what is the difference between the Rating (1=low 6=high) of Europe(all income levels) and Rating (1=low 6=high) of Congo (Republic)?
Give a very brief answer. 1.25. In the year 2012, what is the difference between the Rating (1=low 6=high) of Heavily indebted poor countries and Rating (1=low 6=high) of Congo (Republic)?
Make the answer very short. 0.54. In the year 2012, what is the difference between the Rating (1=low 6=high) in Heavily indebted poor countries and Rating (1=low 6=high) in Sri Lanka?
Provide a short and direct response. -0.96. In the year 2013, what is the difference between the Rating (1=low 6=high) of Europe(all income levels) and Rating (1=low 6=high) of Heavily indebted poor countries?
Your answer should be compact. 0.7. In the year 2013, what is the difference between the Rating (1=low 6=high) in Europe(all income levels) and Rating (1=low 6=high) in Congo (Republic)?
Your answer should be compact. 1.25. In the year 2013, what is the difference between the Rating (1=low 6=high) in Heavily indebted poor countries and Rating (1=low 6=high) in Congo (Republic)?
Give a very brief answer. 0.55. In the year 2013, what is the difference between the Rating (1=low 6=high) in Heavily indebted poor countries and Rating (1=low 6=high) in Sri Lanka?
Provide a short and direct response. -0.95. In the year 2014, what is the difference between the Rating (1=low 6=high) of Europe(all income levels) and Rating (1=low 6=high) of Heavily indebted poor countries?
Your answer should be compact. 0.23. In the year 2014, what is the difference between the Rating (1=low 6=high) in Europe(all income levels) and Rating (1=low 6=high) in Sri Lanka?
Your answer should be very brief. -0.7. In the year 2014, what is the difference between the Rating (1=low 6=high) of Heavily indebted poor countries and Rating (1=low 6=high) of Congo (Republic)?
Provide a short and direct response. 0.57. In the year 2014, what is the difference between the Rating (1=low 6=high) in Heavily indebted poor countries and Rating (1=low 6=high) in Sri Lanka?
Offer a terse response. -0.93. What is the ratio of the Rating (1=low 6=high) in Europe(all income levels) in 2007 to that in 2008?
Offer a terse response. 0.97. What is the ratio of the Rating (1=low 6=high) of Heavily indebted poor countries in 2007 to that in 2008?
Provide a short and direct response. 1.01. What is the ratio of the Rating (1=low 6=high) of Europe(all income levels) in 2007 to that in 2009?
Offer a very short reply. 0.99. What is the ratio of the Rating (1=low 6=high) in Heavily indebted poor countries in 2007 to that in 2009?
Offer a terse response. 1.02. What is the ratio of the Rating (1=low 6=high) in Congo (Republic) in 2007 to that in 2009?
Make the answer very short. 1. What is the ratio of the Rating (1=low 6=high) of Sri Lanka in 2007 to that in 2009?
Give a very brief answer. 1. What is the ratio of the Rating (1=low 6=high) in Europe(all income levels) in 2007 to that in 2010?
Ensure brevity in your answer.  0.99. What is the ratio of the Rating (1=low 6=high) of Heavily indebted poor countries in 2007 to that in 2010?
Ensure brevity in your answer.  1.04. What is the ratio of the Rating (1=low 6=high) of Congo (Republic) in 2007 to that in 2010?
Make the answer very short. 1. What is the ratio of the Rating (1=low 6=high) in Sri Lanka in 2007 to that in 2010?
Your answer should be compact. 1. What is the ratio of the Rating (1=low 6=high) in Europe(all income levels) in 2007 to that in 2011?
Ensure brevity in your answer.  1. What is the ratio of the Rating (1=low 6=high) of Congo (Republic) in 2007 to that in 2011?
Keep it short and to the point. 1. What is the ratio of the Rating (1=low 6=high) of Sri Lanka in 2007 to that in 2011?
Keep it short and to the point. 1. What is the ratio of the Rating (1=low 6=high) of Europe(all income levels) in 2007 to that in 2012?
Make the answer very short. 1. What is the ratio of the Rating (1=low 6=high) of Heavily indebted poor countries in 2007 to that in 2012?
Ensure brevity in your answer.  1.02. What is the ratio of the Rating (1=low 6=high) in Congo (Republic) in 2007 to that in 2012?
Your answer should be compact. 1. What is the ratio of the Rating (1=low 6=high) of Sri Lanka in 2007 to that in 2012?
Give a very brief answer. 1. What is the ratio of the Rating (1=low 6=high) of Heavily indebted poor countries in 2007 to that in 2013?
Provide a short and direct response. 1.02. What is the ratio of the Rating (1=low 6=high) of Europe(all income levels) in 2007 to that in 2014?
Ensure brevity in your answer.  1.14. What is the ratio of the Rating (1=low 6=high) of Heavily indebted poor countries in 2007 to that in 2014?
Provide a short and direct response. 1.01. What is the ratio of the Rating (1=low 6=high) in Europe(all income levels) in 2008 to that in 2009?
Your answer should be compact. 1.03. What is the ratio of the Rating (1=low 6=high) in Heavily indebted poor countries in 2008 to that in 2009?
Provide a short and direct response. 1.01. What is the ratio of the Rating (1=low 6=high) of Congo (Republic) in 2008 to that in 2009?
Your answer should be compact. 1. What is the ratio of the Rating (1=low 6=high) of Europe(all income levels) in 2008 to that in 2010?
Provide a short and direct response. 1.03. What is the ratio of the Rating (1=low 6=high) of Congo (Republic) in 2008 to that in 2010?
Your answer should be compact. 1. What is the ratio of the Rating (1=low 6=high) in Sri Lanka in 2008 to that in 2010?
Offer a very short reply. 1. What is the ratio of the Rating (1=low 6=high) of Europe(all income levels) in 2008 to that in 2011?
Offer a terse response. 1.03. What is the ratio of the Rating (1=low 6=high) in Heavily indebted poor countries in 2008 to that in 2011?
Your answer should be very brief. 1.02. What is the ratio of the Rating (1=low 6=high) of Europe(all income levels) in 2008 to that in 2012?
Offer a very short reply. 1.03. What is the ratio of the Rating (1=low 6=high) of Heavily indebted poor countries in 2008 to that in 2012?
Give a very brief answer. 1.01. What is the ratio of the Rating (1=low 6=high) in Congo (Republic) in 2008 to that in 2012?
Give a very brief answer. 1. What is the ratio of the Rating (1=low 6=high) of Sri Lanka in 2008 to that in 2012?
Offer a terse response. 1. What is the ratio of the Rating (1=low 6=high) in Heavily indebted poor countries in 2008 to that in 2013?
Your answer should be very brief. 1.01. What is the ratio of the Rating (1=low 6=high) of Sri Lanka in 2008 to that in 2013?
Keep it short and to the point. 1. What is the ratio of the Rating (1=low 6=high) of Europe(all income levels) in 2008 to that in 2014?
Your answer should be compact. 1.17. What is the ratio of the Rating (1=low 6=high) of Heavily indebted poor countries in 2008 to that in 2014?
Give a very brief answer. 1. What is the ratio of the Rating (1=low 6=high) in Sri Lanka in 2008 to that in 2014?
Ensure brevity in your answer.  1. What is the ratio of the Rating (1=low 6=high) in Europe(all income levels) in 2009 to that in 2010?
Provide a short and direct response. 1. What is the ratio of the Rating (1=low 6=high) in Heavily indebted poor countries in 2009 to that in 2010?
Provide a short and direct response. 1.02. What is the ratio of the Rating (1=low 6=high) in Congo (Republic) in 2009 to that in 2010?
Provide a succinct answer. 1. What is the ratio of the Rating (1=low 6=high) of Sri Lanka in 2009 to that in 2010?
Offer a terse response. 1. What is the ratio of the Rating (1=low 6=high) in Europe(all income levels) in 2009 to that in 2011?
Provide a short and direct response. 1.01. What is the ratio of the Rating (1=low 6=high) in Heavily indebted poor countries in 2009 to that in 2011?
Offer a terse response. 1.01. What is the ratio of the Rating (1=low 6=high) in Europe(all income levels) in 2009 to that in 2012?
Provide a short and direct response. 1.01. What is the ratio of the Rating (1=low 6=high) in Heavily indebted poor countries in 2009 to that in 2012?
Your response must be concise. 1. What is the ratio of the Rating (1=low 6=high) in Europe(all income levels) in 2009 to that in 2013?
Your response must be concise. 1.01. What is the ratio of the Rating (1=low 6=high) in Congo (Republic) in 2009 to that in 2013?
Keep it short and to the point. 1. What is the ratio of the Rating (1=low 6=high) in Europe(all income levels) in 2009 to that in 2014?
Your answer should be compact. 1.14. What is the ratio of the Rating (1=low 6=high) of Heavily indebted poor countries in 2009 to that in 2014?
Provide a short and direct response. 1. What is the ratio of the Rating (1=low 6=high) of Congo (Republic) in 2009 to that in 2014?
Ensure brevity in your answer.  1. What is the ratio of the Rating (1=low 6=high) of Europe(all income levels) in 2010 to that in 2011?
Your answer should be compact. 1.01. What is the ratio of the Rating (1=low 6=high) of Heavily indebted poor countries in 2010 to that in 2011?
Your response must be concise. 0.99. What is the ratio of the Rating (1=low 6=high) of Sri Lanka in 2010 to that in 2011?
Your response must be concise. 1. What is the ratio of the Rating (1=low 6=high) of Europe(all income levels) in 2010 to that in 2012?
Your answer should be compact. 1.01. What is the ratio of the Rating (1=low 6=high) of Europe(all income levels) in 2010 to that in 2013?
Your answer should be compact. 1.01. What is the ratio of the Rating (1=low 6=high) in Heavily indebted poor countries in 2010 to that in 2013?
Make the answer very short. 0.98. What is the ratio of the Rating (1=low 6=high) in Europe(all income levels) in 2010 to that in 2014?
Ensure brevity in your answer.  1.14. What is the ratio of the Rating (1=low 6=high) of Heavily indebted poor countries in 2010 to that in 2014?
Your answer should be compact. 0.98. What is the ratio of the Rating (1=low 6=high) of Congo (Republic) in 2010 to that in 2014?
Offer a very short reply. 1. What is the ratio of the Rating (1=low 6=high) in Sri Lanka in 2010 to that in 2014?
Provide a succinct answer. 1. What is the ratio of the Rating (1=low 6=high) in Europe(all income levels) in 2011 to that in 2012?
Ensure brevity in your answer.  1. What is the ratio of the Rating (1=low 6=high) in Heavily indebted poor countries in 2011 to that in 2012?
Ensure brevity in your answer.  1. What is the ratio of the Rating (1=low 6=high) of Sri Lanka in 2011 to that in 2012?
Your answer should be very brief. 1. What is the ratio of the Rating (1=low 6=high) of Heavily indebted poor countries in 2011 to that in 2013?
Ensure brevity in your answer.  0.99. What is the ratio of the Rating (1=low 6=high) in Congo (Republic) in 2011 to that in 2013?
Give a very brief answer. 1. What is the ratio of the Rating (1=low 6=high) in Sri Lanka in 2011 to that in 2013?
Your answer should be compact. 1. What is the ratio of the Rating (1=low 6=high) in Europe(all income levels) in 2011 to that in 2014?
Offer a terse response. 1.14. What is the ratio of the Rating (1=low 6=high) in Heavily indebted poor countries in 2011 to that in 2014?
Provide a short and direct response. 0.99. What is the ratio of the Rating (1=low 6=high) of Congo (Republic) in 2011 to that in 2014?
Your answer should be compact. 1. What is the ratio of the Rating (1=low 6=high) of Heavily indebted poor countries in 2012 to that in 2013?
Give a very brief answer. 1. What is the ratio of the Rating (1=low 6=high) in Congo (Republic) in 2012 to that in 2013?
Ensure brevity in your answer.  1. What is the ratio of the Rating (1=low 6=high) in Europe(all income levels) in 2012 to that in 2014?
Your answer should be compact. 1.14. What is the ratio of the Rating (1=low 6=high) of Congo (Republic) in 2012 to that in 2014?
Ensure brevity in your answer.  1. What is the ratio of the Rating (1=low 6=high) of Europe(all income levels) in 2013 to that in 2014?
Your response must be concise. 1.14. What is the ratio of the Rating (1=low 6=high) of Congo (Republic) in 2013 to that in 2014?
Ensure brevity in your answer.  1. What is the difference between the highest and the second highest Rating (1=low 6=high) of Europe(all income levels)?
Provide a short and direct response. 0.1. What is the difference between the highest and the second highest Rating (1=low 6=high) in Heavily indebted poor countries?
Offer a very short reply. 0.03. What is the difference between the highest and the second highest Rating (1=low 6=high) of Congo (Republic)?
Offer a very short reply. 0. What is the difference between the highest and the lowest Rating (1=low 6=high) in Europe(all income levels)?
Keep it short and to the point. 0.57. What is the difference between the highest and the lowest Rating (1=low 6=high) of Heavily indebted poor countries?
Keep it short and to the point. 0.11. What is the difference between the highest and the lowest Rating (1=low 6=high) in Congo (Republic)?
Provide a succinct answer. 0. What is the difference between the highest and the lowest Rating (1=low 6=high) in Sri Lanka?
Your answer should be compact. 0. 